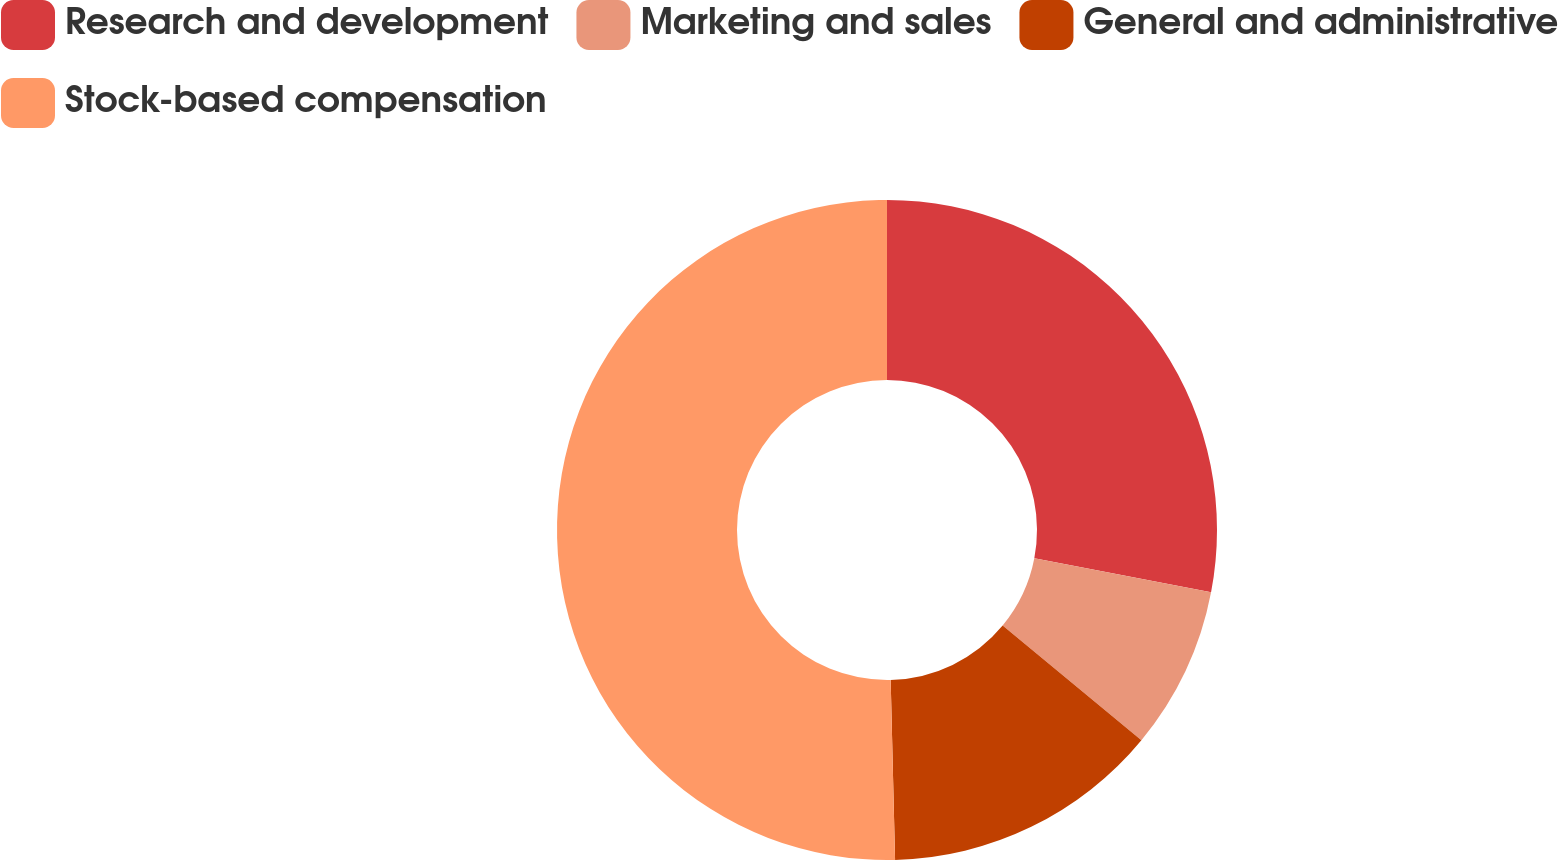<chart> <loc_0><loc_0><loc_500><loc_500><pie_chart><fcel>Research and development<fcel>Marketing and sales<fcel>General and administrative<fcel>Stock-based compensation<nl><fcel>28.02%<fcel>7.97%<fcel>13.62%<fcel>50.39%<nl></chart> 